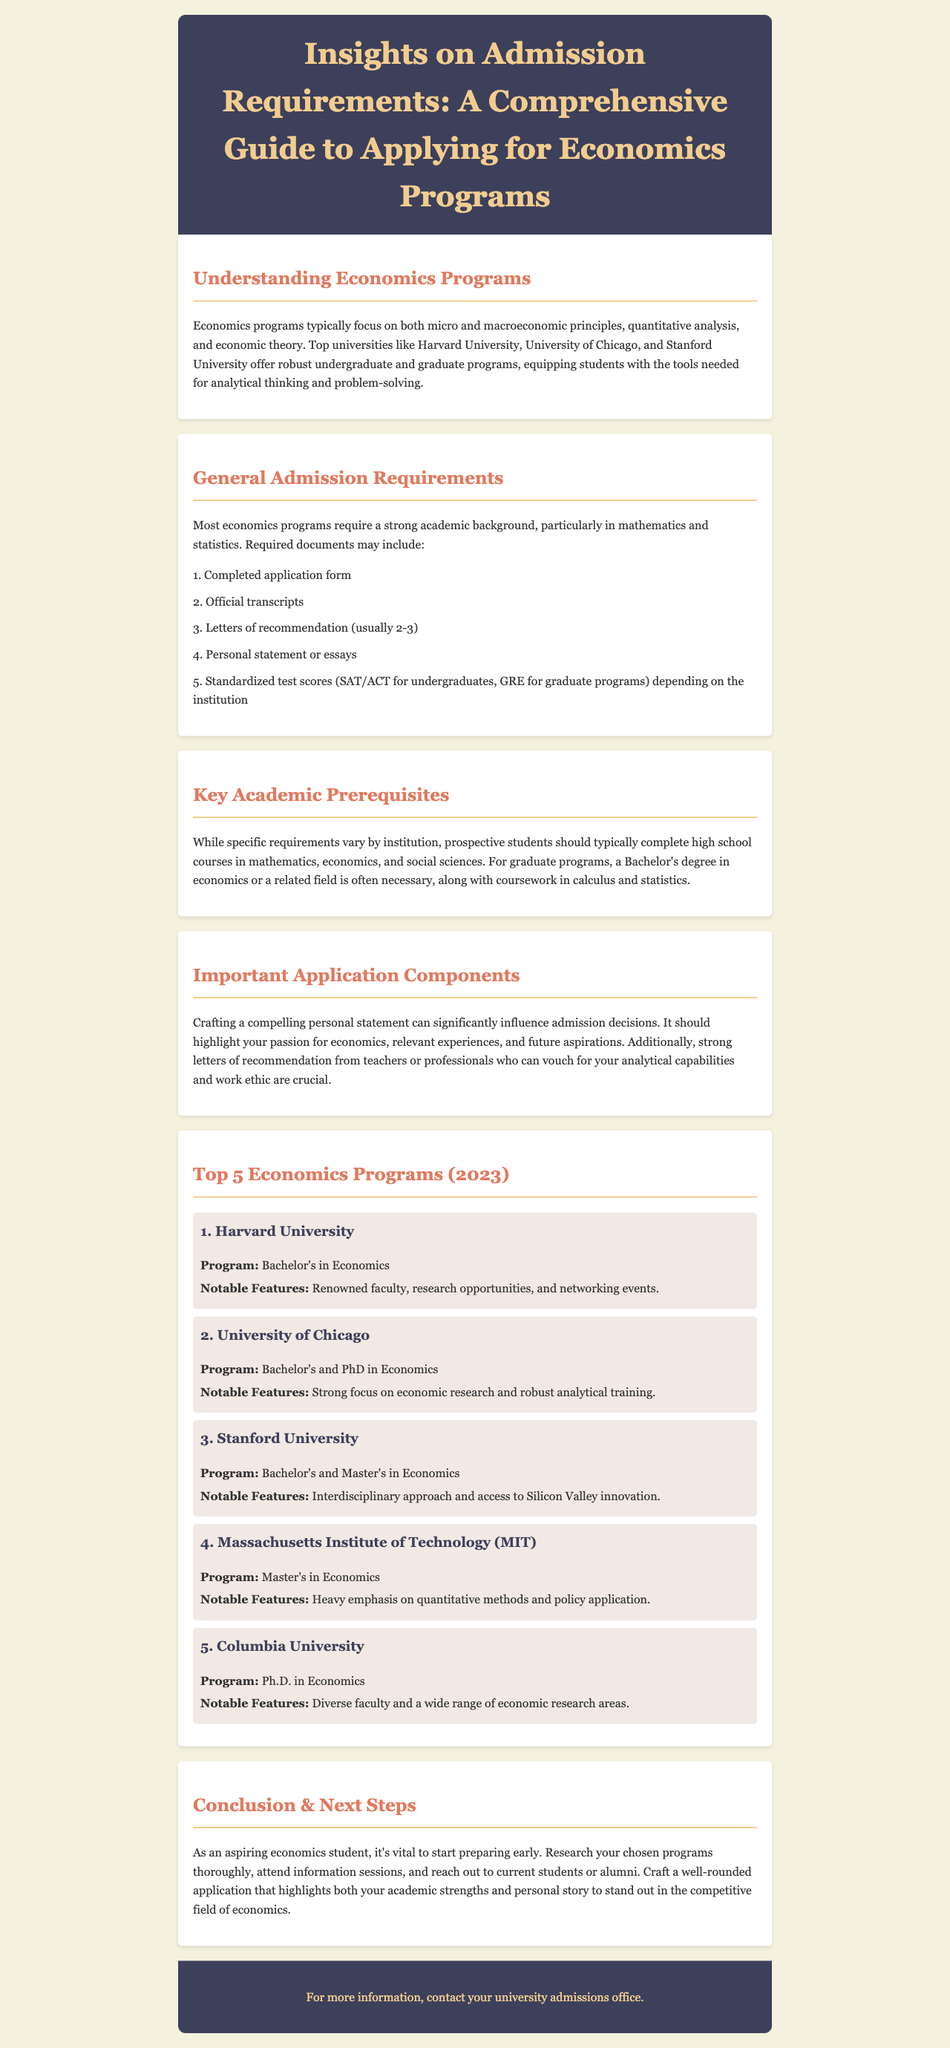What are the top three universities for economics programs? The top three universities listed in the document are Harvard University, University of Chicago, and Stanford University.
Answer: Harvard University, University of Chicago, Stanford University What standardized test scores may be required for admission? The document mentions SAT/ACT for undergraduates and GRE for graduate programs as standardized test requirements.
Answer: SAT/ACT, GRE How many letters of recommendation are usually required? The typical requirement for letters of recommendation is mentioned as usually 2-3 in the document.
Answer: 2-3 What is a key feature of the economics program at MIT? The document specifies that MIT emphasizes quantitative methods and policy application in its economics program.
Answer: Quantitative methods and policy application What is generally required for a graduate program in economics? A Bachelor's degree in economics or a related field, along with coursework in calculus and statistics, is generally required.
Answer: Bachelor's degree in economics or a related field What should a personal statement highlight according to the document? The personal statement should highlight your passion for economics, relevant experiences, and future aspirations.
Answer: Passion for economics, relevant experiences, future aspirations Which university offers a Ph.D. in Economics according to the document? Columbia University is identified as offering a Ph.D. in Economics.
Answer: Columbia University What is the main advice given to aspiring economics students? The document advises aspiring students to start preparing early and craft a well-rounded application.
Answer: Prepare early, craft a well-rounded application 